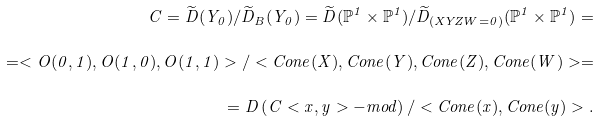<formula> <loc_0><loc_0><loc_500><loc_500>C = \widetilde { D } ( Y _ { 0 } ) / \widetilde { D } _ { B } ( Y _ { 0 } ) = \widetilde { D } ( \mathbb { P } ^ { 1 } \times \mathbb { P } ^ { 1 } ) / \widetilde { D } _ { ( X Y Z W = 0 ) } ( \mathbb { P } ^ { 1 } \times \mathbb { P } ^ { 1 } ) = \\ = < O ( 0 , 1 ) , O ( 1 , 0 ) , O ( 1 , 1 ) > / < C o n e ( X ) , C o n e ( Y ) , C o n e ( Z ) , C o n e ( W ) > = \\ = D \left ( C < x , y > - m o d \right ) / < C o n e ( x ) , C o n e ( y ) > .</formula> 